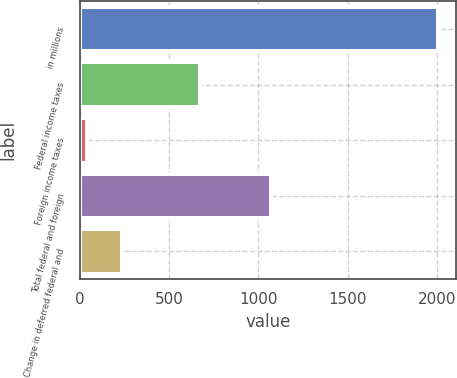Convert chart. <chart><loc_0><loc_0><loc_500><loc_500><bar_chart><fcel>in millions<fcel>Federal income taxes<fcel>Foreign income taxes<fcel>Total federal and foreign<fcel>Change in deferred federal and<nl><fcel>2007<fcel>675<fcel>42<fcel>1068<fcel>238.5<nl></chart> 